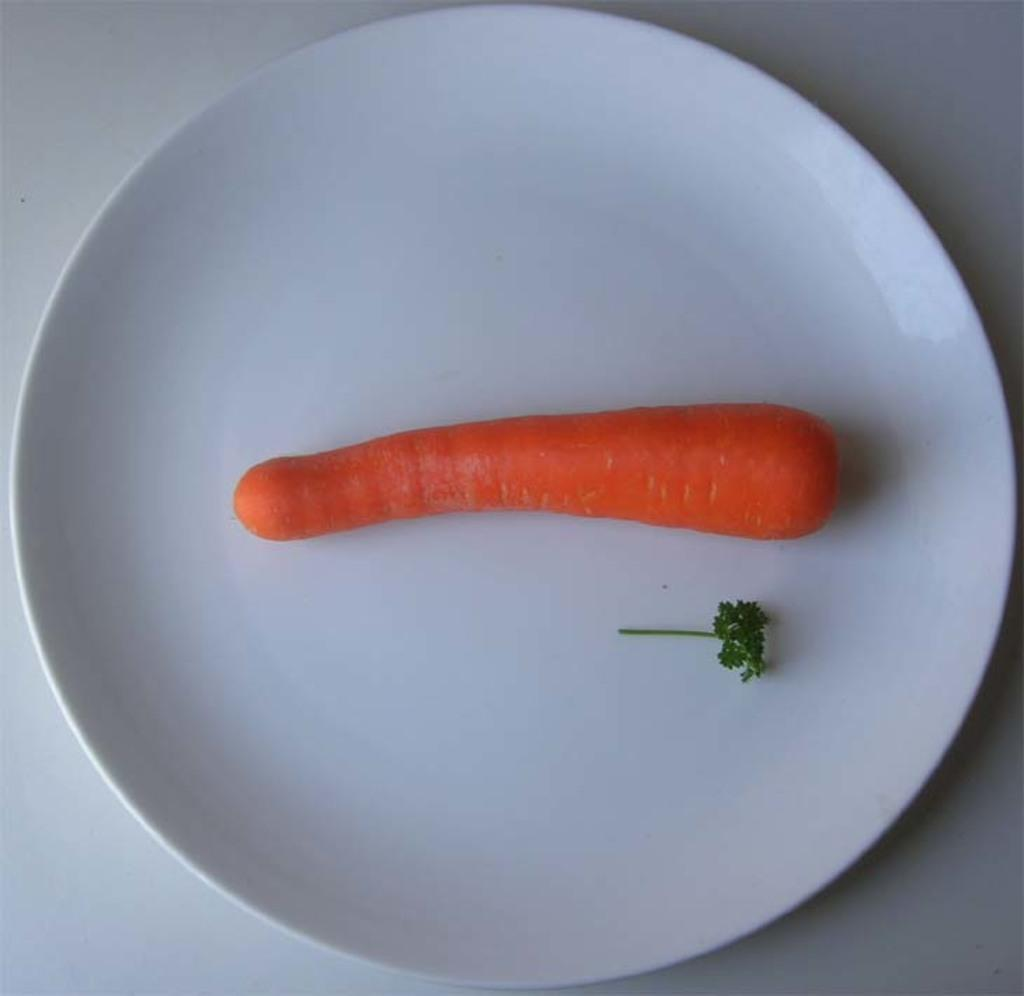What object is present on the plate in the image? There is a white plate in the image, and a carrot and leafy vegetable are on the plate. What color is the plate in the image? The plate in the image is white. What can be seen in the background of the image? The background of the image is white. What type of wave can be seen in the image? There is no wave present in the image; it features a white plate with a carrot and leafy vegetable. Is this a birthday celebration, as indicated by the image? There is no indication in the image that it is a birthday celebration. 